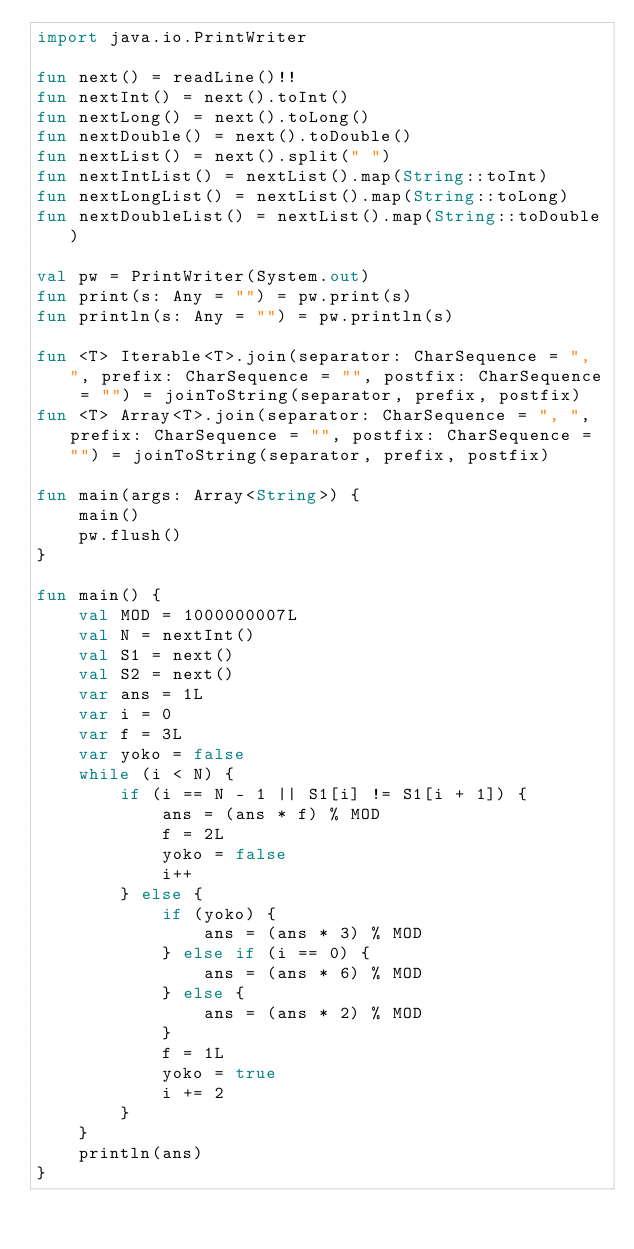<code> <loc_0><loc_0><loc_500><loc_500><_Kotlin_>import java.io.PrintWriter

fun next() = readLine()!!
fun nextInt() = next().toInt()
fun nextLong() = next().toLong()
fun nextDouble() = next().toDouble()
fun nextList() = next().split(" ")
fun nextIntList() = nextList().map(String::toInt)
fun nextLongList() = nextList().map(String::toLong)
fun nextDoubleList() = nextList().map(String::toDouble)

val pw = PrintWriter(System.out)
fun print(s: Any = "") = pw.print(s)
fun println(s: Any = "") = pw.println(s)

fun <T> Iterable<T>.join(separator: CharSequence = ", ", prefix: CharSequence = "", postfix: CharSequence = "") = joinToString(separator, prefix, postfix)
fun <T> Array<T>.join(separator: CharSequence = ", ", prefix: CharSequence = "", postfix: CharSequence = "") = joinToString(separator, prefix, postfix)

fun main(args: Array<String>) {
    main()
    pw.flush()
}

fun main() {
    val MOD = 1000000007L
    val N = nextInt()
    val S1 = next()
    val S2 = next()
    var ans = 1L
    var i = 0
    var f = 3L
    var yoko = false
    while (i < N) {
        if (i == N - 1 || S1[i] != S1[i + 1]) {
            ans = (ans * f) % MOD
            f = 2L
            yoko = false
            i++
        } else {
            if (yoko) {
                ans = (ans * 3) % MOD
            } else if (i == 0) {
                ans = (ans * 6) % MOD
            } else {
                ans = (ans * 2) % MOD
            }
            f = 1L
            yoko = true
            i += 2
        }
    }
    println(ans)
}</code> 